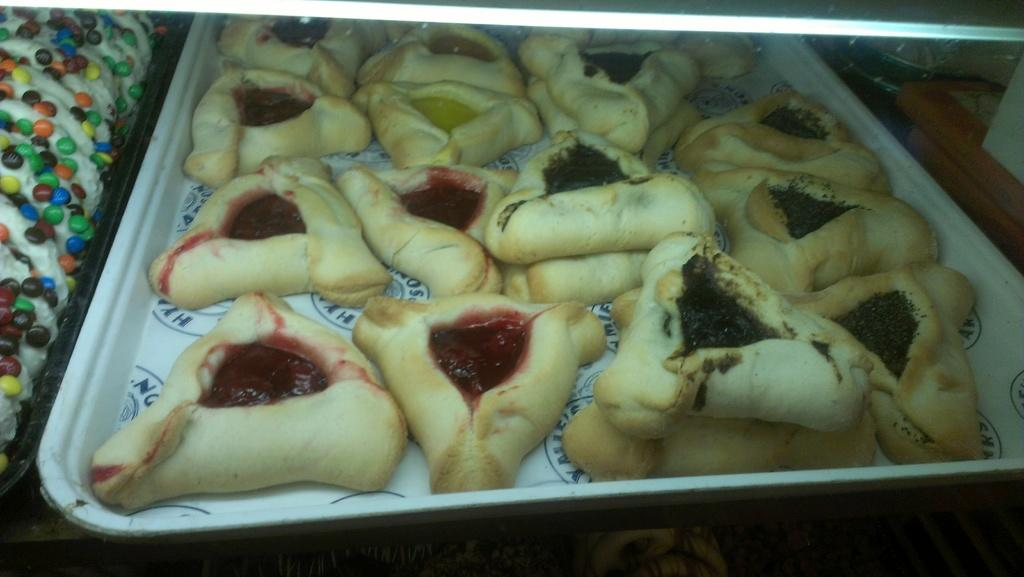What is present on the trays in the image? There are trays with food in the image. Can you describe the objects in the right top area of the image? Unfortunately, the provided facts do not give any information about the objects in the right top area of the image. What type of animals can be seen at the zoo in the image? There is no zoo present in the image, so it is not possible to determine what, if any, animals might be seen. 